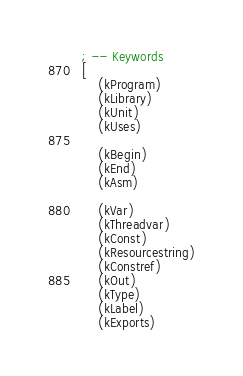<code> <loc_0><loc_0><loc_500><loc_500><_Scheme_>; -- Keywords
[
	(kProgram)
	(kLibrary)
	(kUnit)
	(kUses)

	(kBegin)
	(kEnd)
	(kAsm)

	(kVar)
	(kThreadvar)
	(kConst)
	(kResourcestring)
	(kConstref)
	(kOut)
	(kType)
	(kLabel)
	(kExports)
</code> 